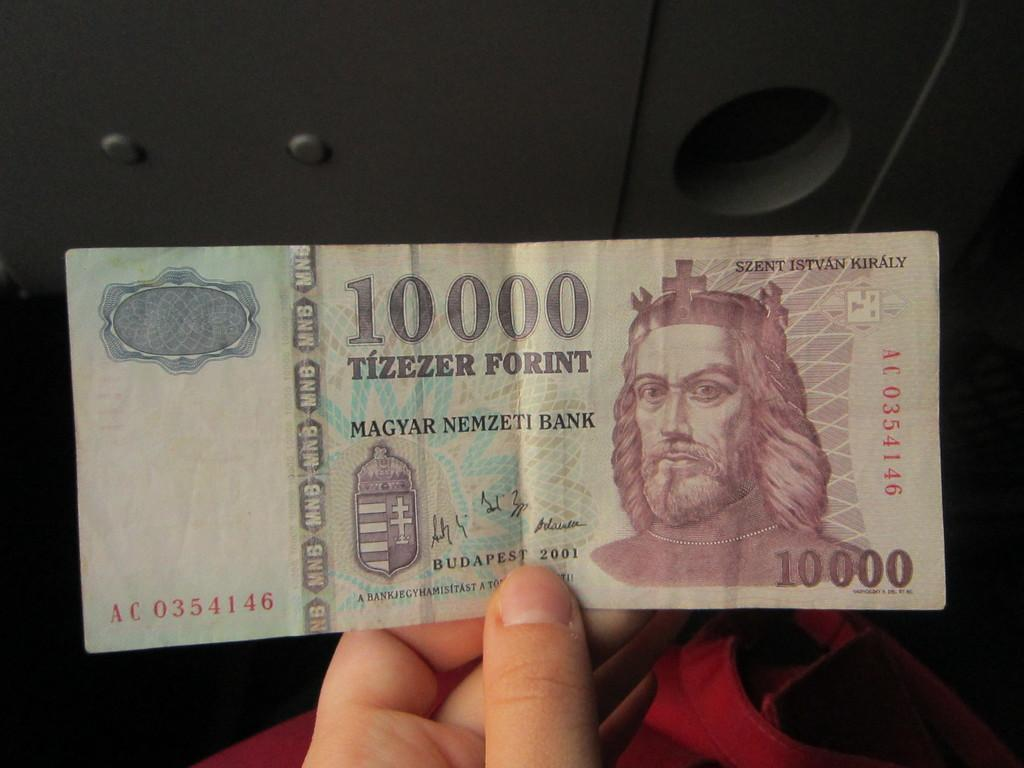What can be seen in the image related to a person's hand? There is a person's hand in the image. What is the hand holding? The hand is holding a currency note. What color is the orange in the image? There is no orange present in the image. Which direction is the person facing in the image? The direction the person is facing cannot be determined from the image, as only the hand is visible. 